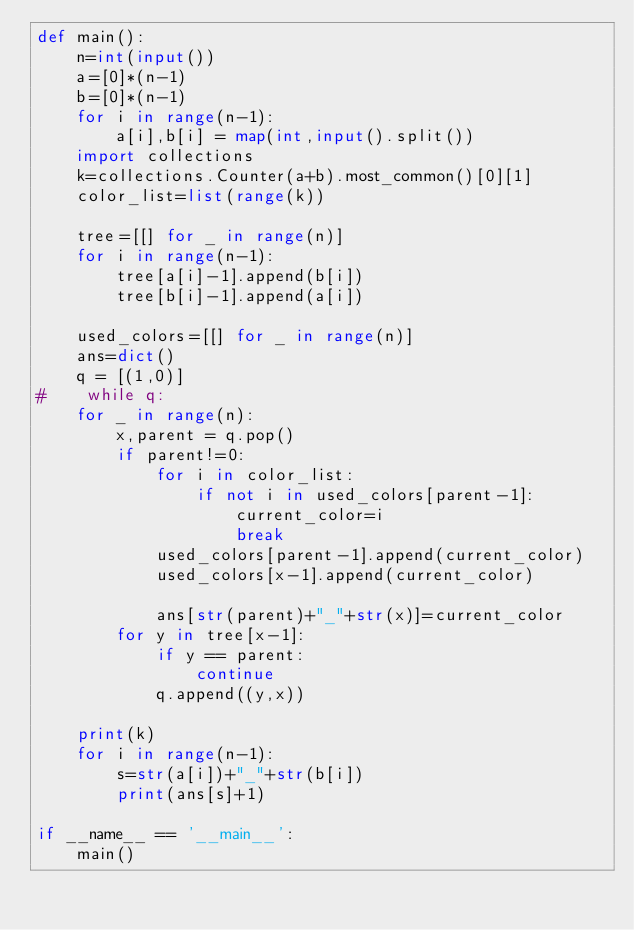<code> <loc_0><loc_0><loc_500><loc_500><_Python_>def main():
    n=int(input())
    a=[0]*(n-1)
    b=[0]*(n-1)
    for i in range(n-1):
        a[i],b[i] = map(int,input().split())
    import collections
    k=collections.Counter(a+b).most_common()[0][1]
    color_list=list(range(k))
    
    tree=[[] for _ in range(n)]
    for i in range(n-1):
        tree[a[i]-1].append(b[i])
        tree[b[i]-1].append(a[i])
        
    used_colors=[[] for _ in range(n)]
    ans=dict()
    q = [(1,0)]
#    while q:
    for _ in range(n):
        x,parent = q.pop()
        if parent!=0:
            for i in color_list:
                if not i in used_colors[parent-1]:
                    current_color=i
                    break
            used_colors[parent-1].append(current_color)
            used_colors[x-1].append(current_color)
        
            ans[str(parent)+"_"+str(x)]=current_color
        for y in tree[x-1]:
            if y == parent:
                continue
            q.append((y,x))
    
    print(k)
    for i in range(n-1):
        s=str(a[i])+"_"+str(b[i])
        print(ans[s]+1)
    
if __name__ == '__main__':
    main()</code> 